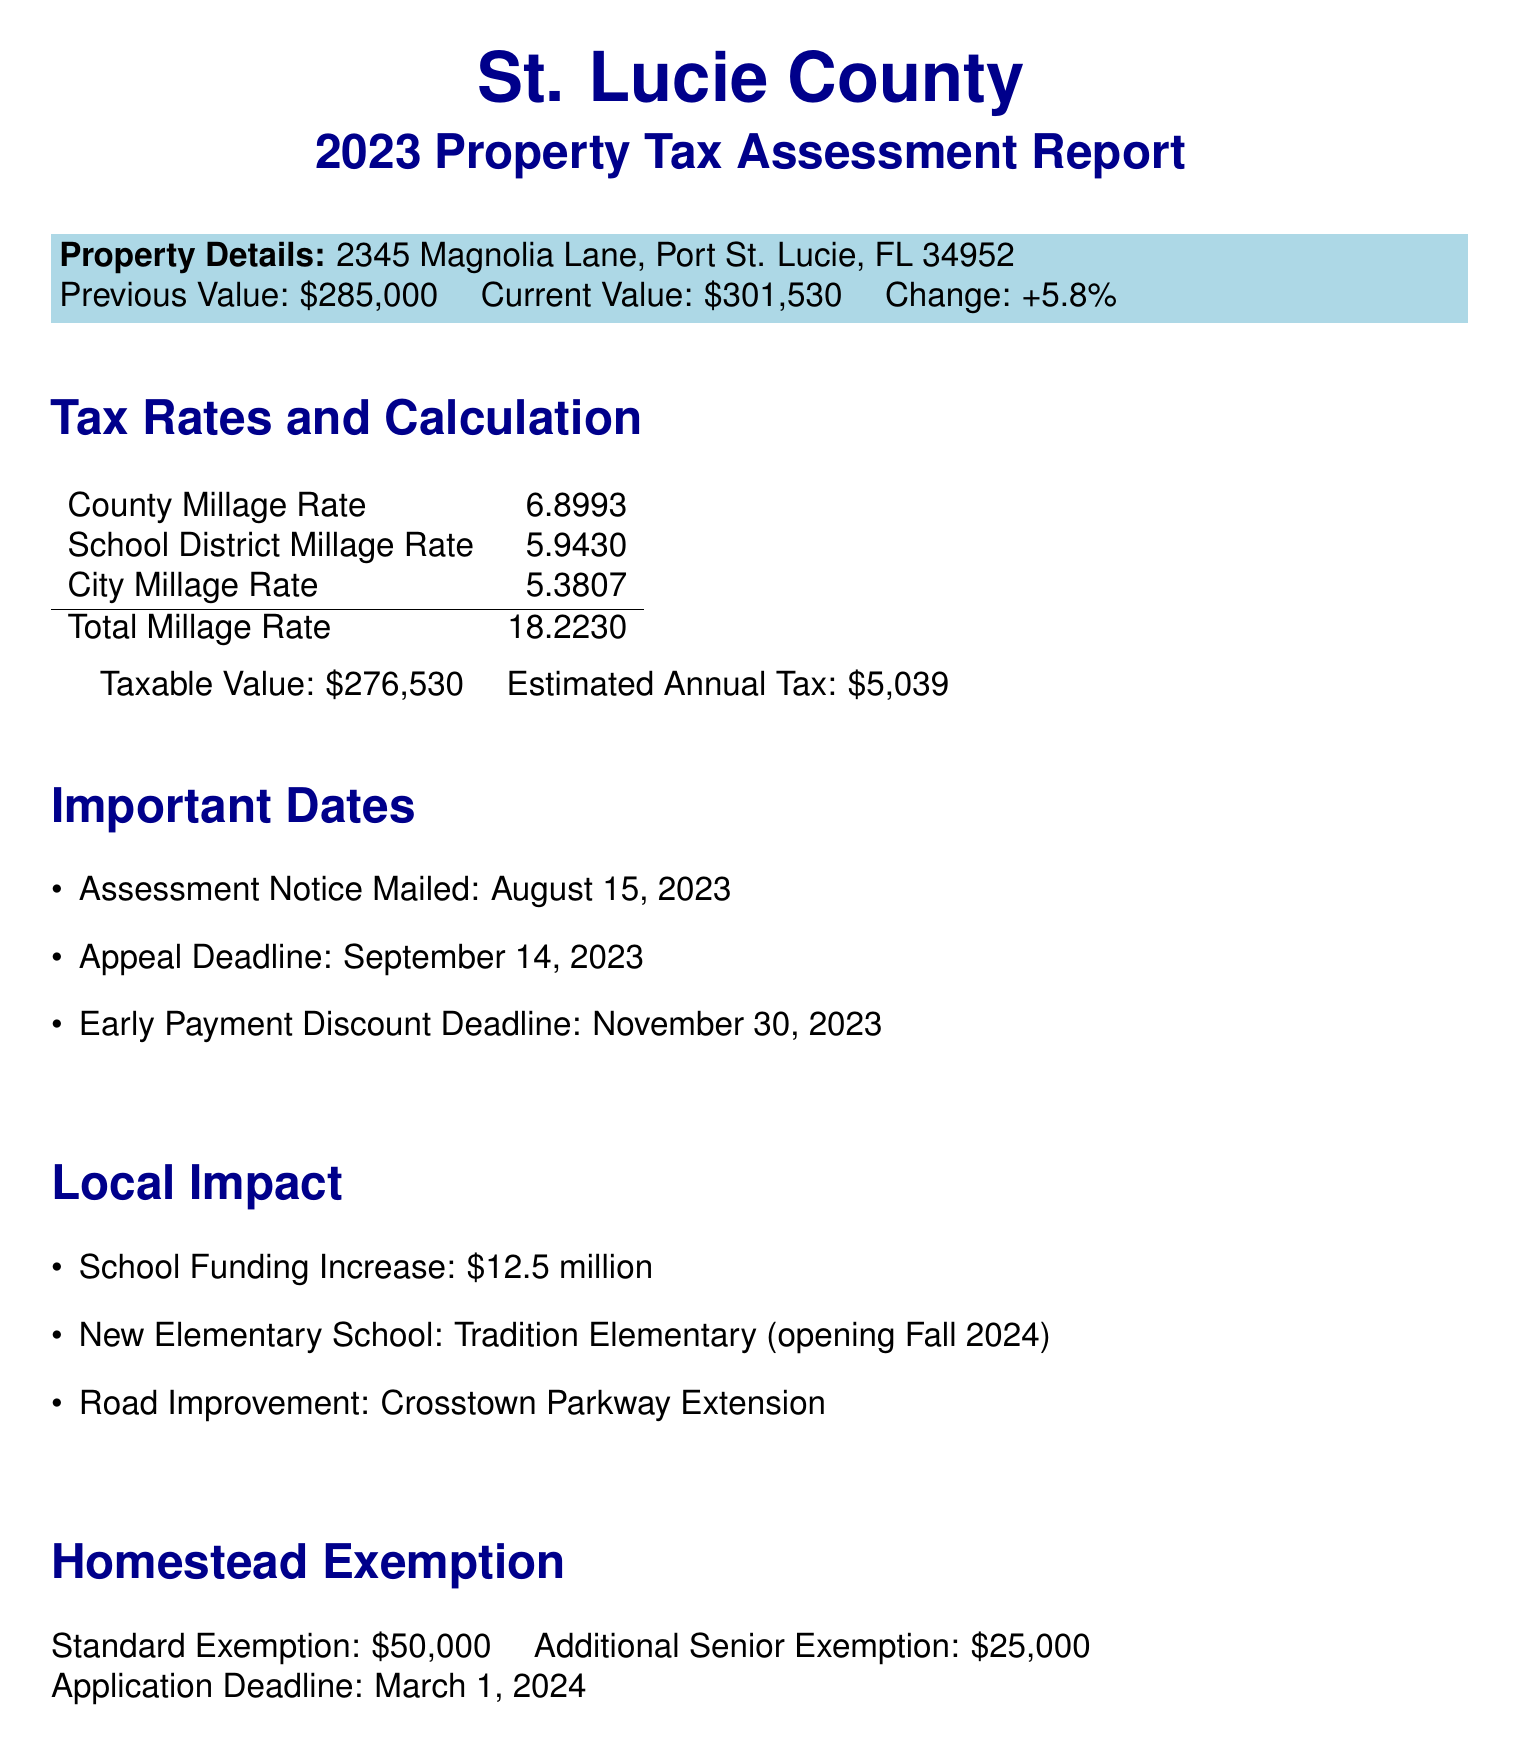what is the average home value change for 2023? The average home value change is indicated in the property tax overview section of the document.
Answer: +5.8% what is the previous assessed value of the property at 2345 Magnolia Lane? The previous assessed value is listed in the personal property details section of the document.
Answer: $285,000 what is the total millage rate in St. Lucie County? The total millage rate is calculated and presented in the tax rates section of the document.
Answer: 18.2230 when is the appeal deadline for property tax assessments? The appeal deadline is specified in the important dates section of the document.
Answer: September 14, 2023 how much will the school funding increase by? The local impact section of the document provides this information.
Answer: $12.5 million what is the standard homestead exemption amount? The standard homestead exemption is detailed in the homestead exemption section of the document.
Answer: $50,000 what are the payment options available for property tax? The payment options are listed in the property tax calculation section of the document.
Answer: Annual, Quarterly, Monthly which new elementary school is opening in Fall 2024? The new elementary school is mentioned in the local impact section of the document.
Answer: Tradition Elementary 